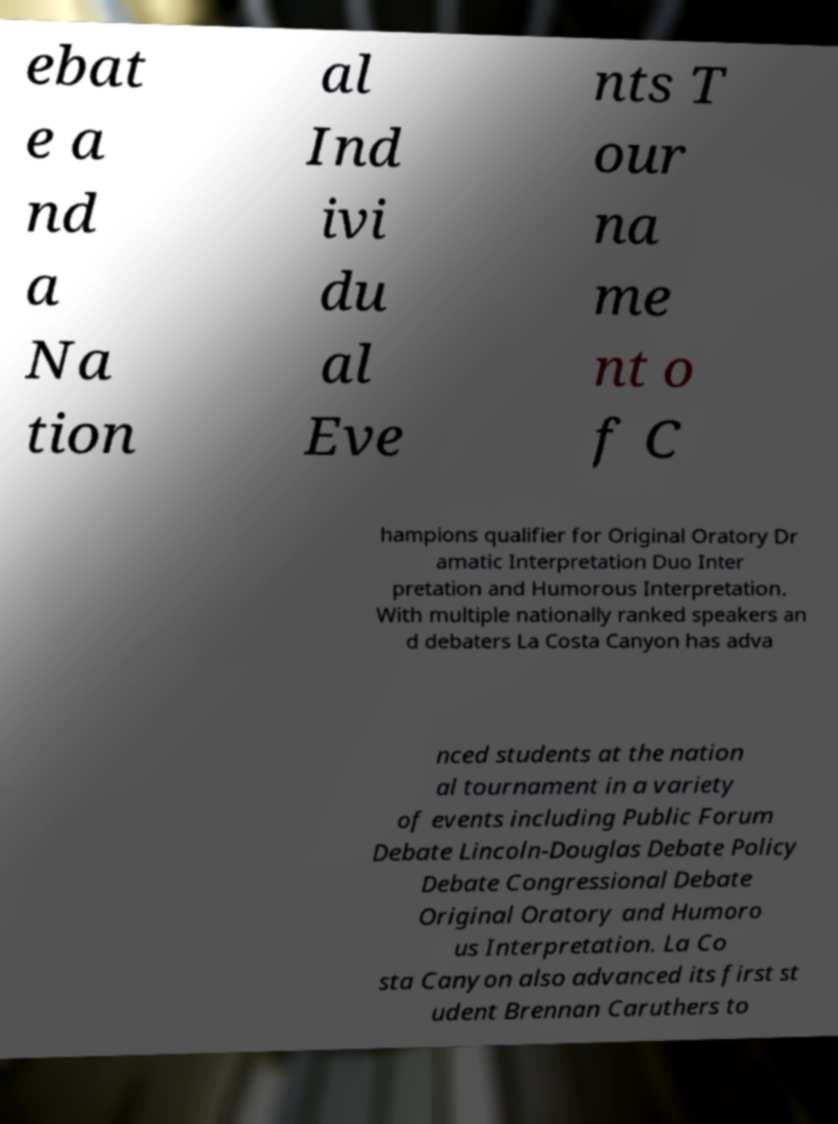Please read and relay the text visible in this image. What does it say? ebat e a nd a Na tion al Ind ivi du al Eve nts T our na me nt o f C hampions qualifier for Original Oratory Dr amatic Interpretation Duo Inter pretation and Humorous Interpretation. With multiple nationally ranked speakers an d debaters La Costa Canyon has adva nced students at the nation al tournament in a variety of events including Public Forum Debate Lincoln-Douglas Debate Policy Debate Congressional Debate Original Oratory and Humoro us Interpretation. La Co sta Canyon also advanced its first st udent Brennan Caruthers to 